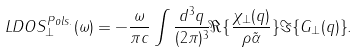<formula> <loc_0><loc_0><loc_500><loc_500>L D O S ^ { P o l s . } _ { \perp } ( \omega ) = - \frac { \omega } { \pi c } \int \frac { d ^ { 3 } q } { ( 2 \pi ) ^ { 3 } } \Re { \{ \frac { \chi _ { \perp } ( q ) } { \rho \tilde { \alpha } } \} } \Im { \{ G _ { \perp } ( q ) \} } .</formula> 